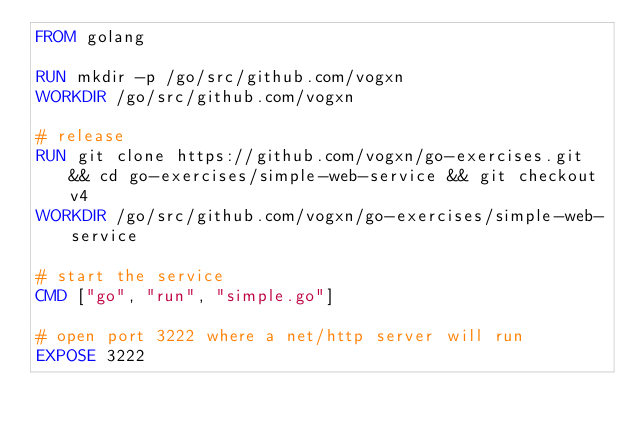Convert code to text. <code><loc_0><loc_0><loc_500><loc_500><_Dockerfile_>FROM golang

RUN mkdir -p /go/src/github.com/vogxn 
WORKDIR /go/src/github.com/vogxn

# release
RUN git clone https://github.com/vogxn/go-exercises.git && cd go-exercises/simple-web-service && git checkout v4
WORKDIR /go/src/github.com/vogxn/go-exercises/simple-web-service

# start the service
CMD ["go", "run", "simple.go"]

# open port 3222 where a net/http server will run
EXPOSE 3222

</code> 